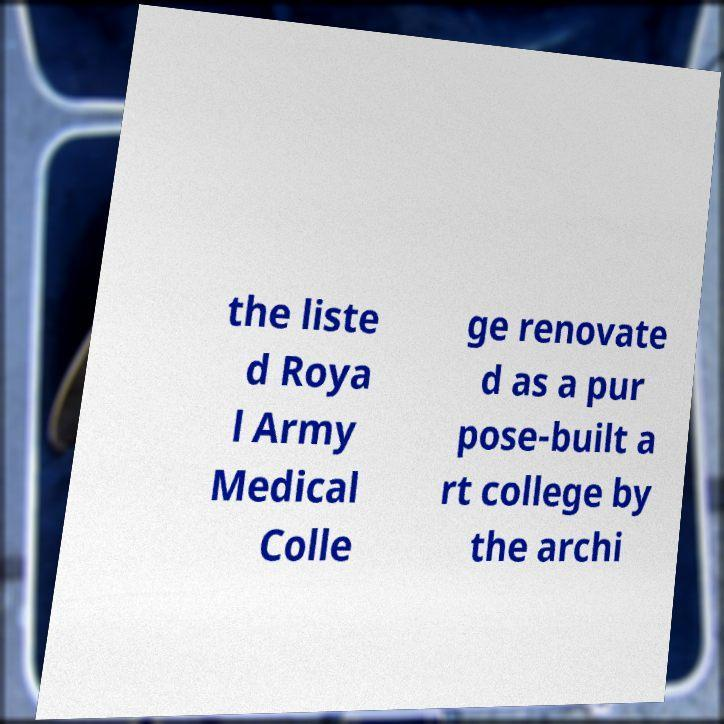What messages or text are displayed in this image? I need them in a readable, typed format. the liste d Roya l Army Medical Colle ge renovate d as a pur pose-built a rt college by the archi 